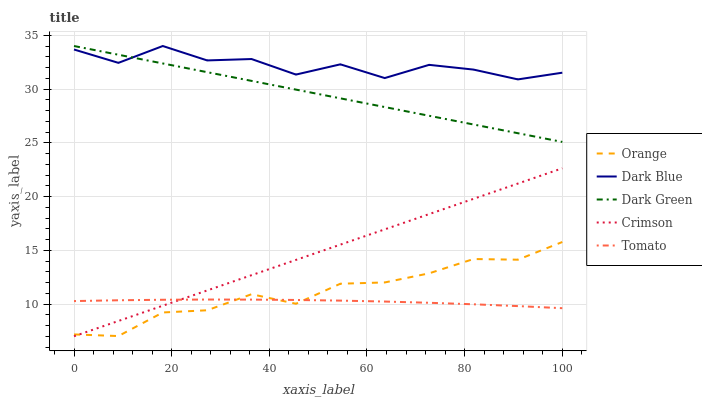Does Tomato have the minimum area under the curve?
Answer yes or no. Yes. Does Dark Blue have the maximum area under the curve?
Answer yes or no. Yes. Does Dark Blue have the minimum area under the curve?
Answer yes or no. No. Does Tomato have the maximum area under the curve?
Answer yes or no. No. Is Crimson the smoothest?
Answer yes or no. Yes. Is Dark Blue the roughest?
Answer yes or no. Yes. Is Tomato the smoothest?
Answer yes or no. No. Is Tomato the roughest?
Answer yes or no. No. Does Tomato have the lowest value?
Answer yes or no. No. Does Dark Green have the highest value?
Answer yes or no. Yes. Does Tomato have the highest value?
Answer yes or no. No. Is Tomato less than Dark Blue?
Answer yes or no. Yes. Is Dark Blue greater than Crimson?
Answer yes or no. Yes. Does Crimson intersect Orange?
Answer yes or no. Yes. Is Crimson less than Orange?
Answer yes or no. No. Is Crimson greater than Orange?
Answer yes or no. No. Does Tomato intersect Dark Blue?
Answer yes or no. No. 